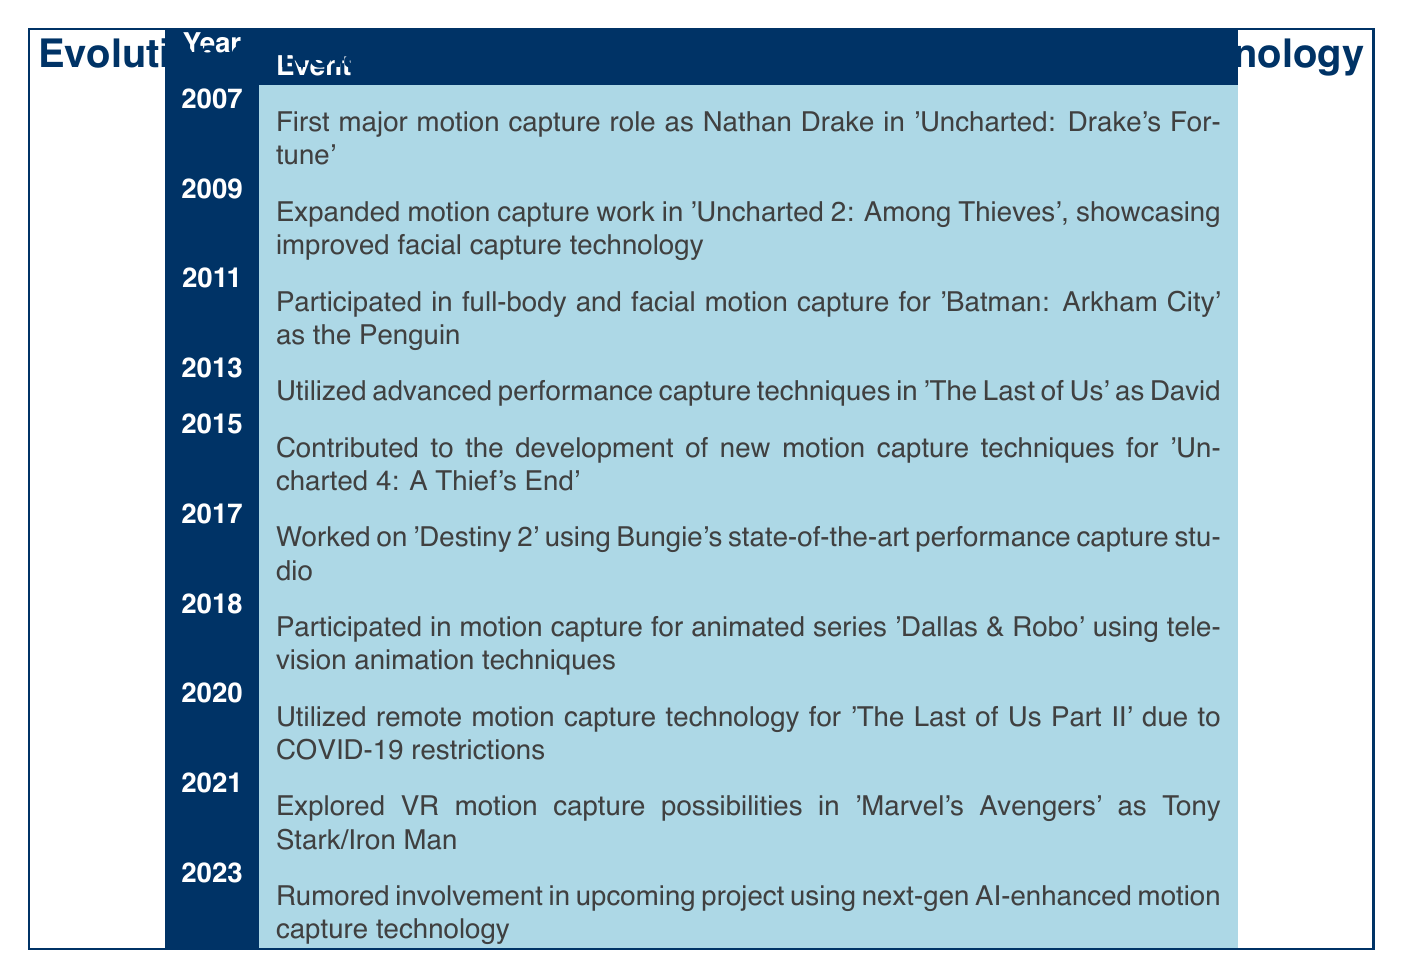What was Nolan North's first major motion capture role? The table states that the first major motion capture role was in 2007 as Nathan Drake in 'Uncharted: Drake's Fortune.'
Answer: Nathan Drake in 'Uncharted: Drake's Fortune' In which year did Nolan North utilize advanced performance capture techniques? The table indicates that advanced performance capture techniques were utilized in 2013 for 'The Last of Us' as David.
Answer: 2013 How many events are listed between 2007 and 2017? There are a total of 6 events listed from 2007 to 2017 by counting them: 2007, 2009, 2011, 2013, 2015, and 2017.
Answer: 6 Was Nolan North involved in motion capture for 'Dallas & Robo'? Yes, the table confirms that he participated in motion capture for the animated series 'Dallas & Robo' in 2018.
Answer: Yes Which event occurred immediately after Nolan North's participation in 'Uncharted 4: A Thief's End'? The event after 'Uncharted 4: A Thief's End,' which took place in 2015, is his work on 'Destiny 2' in 2017.
Answer: 'Destiny 2' in 2017 What is the time span between Nolan North's first major role and his rumored involvement in a next-gen AI project? The first major role was in 2007 and the rumored project is in 2023, giving a time span of 16 years from 2007 to 2023.
Answer: 16 years How did the COVID-19 pandemic affect Nolan North's motion capture work? According to the table, in 2020 he utilized remote motion capture technology for 'The Last of Us Part II' due to COVID-19 restrictions.
Answer: Used remote motion capture technology In how many projects did Nolan North work between 2015 and 2021? Counting the projects in the timeline from 2015 to 2021 gives a total of 3: 'Uncharted 4: A Thief's End' (2015), 'Destiny 2' (2017), and 'Marvel's Avengers' (2021).
Answer: 3 What improvement in motion capture technology was showcased in 'Uncharted 2: Among Thieves'? The table notes that 'Uncharted 2: Among Thieves' in 2009 showcased improved facial capture technology.
Answer: Improved facial capture technology 